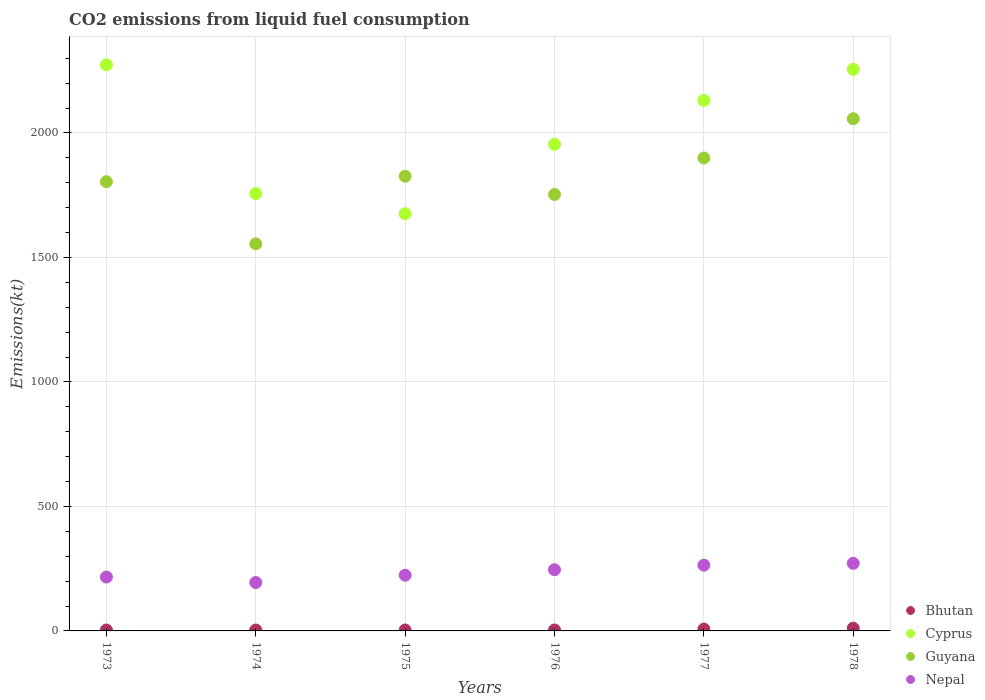Is the number of dotlines equal to the number of legend labels?
Offer a terse response. Yes. What is the amount of CO2 emitted in Cyprus in 1978?
Ensure brevity in your answer.  2255.2. Across all years, what is the maximum amount of CO2 emitted in Guyana?
Make the answer very short. 2057.19. Across all years, what is the minimum amount of CO2 emitted in Nepal?
Provide a succinct answer. 194.35. In which year was the amount of CO2 emitted in Bhutan maximum?
Your response must be concise. 1978. In which year was the amount of CO2 emitted in Guyana minimum?
Your answer should be very brief. 1974. What is the total amount of CO2 emitted in Bhutan in the graph?
Offer a terse response. 33. What is the difference between the amount of CO2 emitted in Nepal in 1974 and that in 1975?
Offer a very short reply. -29.34. What is the difference between the amount of CO2 emitted in Bhutan in 1973 and the amount of CO2 emitted in Guyana in 1975?
Provide a short and direct response. -1822.5. What is the average amount of CO2 emitted in Nepal per year?
Keep it short and to the point. 235.91. In the year 1974, what is the difference between the amount of CO2 emitted in Bhutan and amount of CO2 emitted in Nepal?
Make the answer very short. -190.68. In how many years, is the amount of CO2 emitted in Nepal greater than 800 kt?
Give a very brief answer. 0. What is the ratio of the amount of CO2 emitted in Guyana in 1974 to that in 1977?
Provide a succinct answer. 0.82. Is the amount of CO2 emitted in Guyana in 1973 less than that in 1975?
Give a very brief answer. Yes. What is the difference between the highest and the second highest amount of CO2 emitted in Bhutan?
Provide a short and direct response. 3.67. What is the difference between the highest and the lowest amount of CO2 emitted in Guyana?
Provide a short and direct response. 502.38. Is the sum of the amount of CO2 emitted in Cyprus in 1974 and 1977 greater than the maximum amount of CO2 emitted in Guyana across all years?
Your answer should be compact. Yes. Is it the case that in every year, the sum of the amount of CO2 emitted in Bhutan and amount of CO2 emitted in Nepal  is greater than the amount of CO2 emitted in Guyana?
Offer a very short reply. No. Does the amount of CO2 emitted in Bhutan monotonically increase over the years?
Your response must be concise. No. Is the amount of CO2 emitted in Cyprus strictly greater than the amount of CO2 emitted in Bhutan over the years?
Your answer should be compact. Yes. How many dotlines are there?
Your answer should be compact. 4. How many legend labels are there?
Ensure brevity in your answer.  4. What is the title of the graph?
Keep it short and to the point. CO2 emissions from liquid fuel consumption. Does "Senegal" appear as one of the legend labels in the graph?
Offer a terse response. No. What is the label or title of the Y-axis?
Offer a very short reply. Emissions(kt). What is the Emissions(kt) in Bhutan in 1973?
Make the answer very short. 3.67. What is the Emissions(kt) in Cyprus in 1973?
Give a very brief answer. 2273.54. What is the Emissions(kt) in Guyana in 1973?
Provide a succinct answer. 1804.16. What is the Emissions(kt) of Nepal in 1973?
Provide a succinct answer. 216.35. What is the Emissions(kt) in Bhutan in 1974?
Ensure brevity in your answer.  3.67. What is the Emissions(kt) in Cyprus in 1974?
Offer a very short reply. 1756.49. What is the Emissions(kt) in Guyana in 1974?
Offer a terse response. 1554.81. What is the Emissions(kt) of Nepal in 1974?
Provide a short and direct response. 194.35. What is the Emissions(kt) in Bhutan in 1975?
Ensure brevity in your answer.  3.67. What is the Emissions(kt) in Cyprus in 1975?
Provide a short and direct response. 1675.82. What is the Emissions(kt) in Guyana in 1975?
Offer a terse response. 1826.17. What is the Emissions(kt) of Nepal in 1975?
Ensure brevity in your answer.  223.69. What is the Emissions(kt) of Bhutan in 1976?
Your response must be concise. 3.67. What is the Emissions(kt) in Cyprus in 1976?
Your answer should be very brief. 1954.51. What is the Emissions(kt) in Guyana in 1976?
Your answer should be very brief. 1752.83. What is the Emissions(kt) of Nepal in 1976?
Provide a short and direct response. 245.69. What is the Emissions(kt) of Bhutan in 1977?
Your answer should be compact. 7.33. What is the Emissions(kt) of Cyprus in 1977?
Your answer should be compact. 2130.53. What is the Emissions(kt) of Guyana in 1977?
Offer a terse response. 1899.51. What is the Emissions(kt) in Nepal in 1977?
Give a very brief answer. 264.02. What is the Emissions(kt) in Bhutan in 1978?
Your response must be concise. 11. What is the Emissions(kt) of Cyprus in 1978?
Ensure brevity in your answer.  2255.2. What is the Emissions(kt) of Guyana in 1978?
Your answer should be compact. 2057.19. What is the Emissions(kt) in Nepal in 1978?
Ensure brevity in your answer.  271.36. Across all years, what is the maximum Emissions(kt) in Bhutan?
Make the answer very short. 11. Across all years, what is the maximum Emissions(kt) of Cyprus?
Ensure brevity in your answer.  2273.54. Across all years, what is the maximum Emissions(kt) in Guyana?
Offer a very short reply. 2057.19. Across all years, what is the maximum Emissions(kt) of Nepal?
Provide a succinct answer. 271.36. Across all years, what is the minimum Emissions(kt) in Bhutan?
Your answer should be compact. 3.67. Across all years, what is the minimum Emissions(kt) of Cyprus?
Make the answer very short. 1675.82. Across all years, what is the minimum Emissions(kt) of Guyana?
Provide a short and direct response. 1554.81. Across all years, what is the minimum Emissions(kt) in Nepal?
Offer a terse response. 194.35. What is the total Emissions(kt) in Bhutan in the graph?
Your answer should be compact. 33. What is the total Emissions(kt) in Cyprus in the graph?
Your answer should be compact. 1.20e+04. What is the total Emissions(kt) of Guyana in the graph?
Provide a succinct answer. 1.09e+04. What is the total Emissions(kt) of Nepal in the graph?
Make the answer very short. 1415.46. What is the difference between the Emissions(kt) of Cyprus in 1973 and that in 1974?
Provide a short and direct response. 517.05. What is the difference between the Emissions(kt) of Guyana in 1973 and that in 1974?
Ensure brevity in your answer.  249.36. What is the difference between the Emissions(kt) in Nepal in 1973 and that in 1974?
Your answer should be very brief. 22. What is the difference between the Emissions(kt) of Bhutan in 1973 and that in 1975?
Provide a succinct answer. 0. What is the difference between the Emissions(kt) of Cyprus in 1973 and that in 1975?
Your answer should be compact. 597.72. What is the difference between the Emissions(kt) in Guyana in 1973 and that in 1975?
Offer a very short reply. -22. What is the difference between the Emissions(kt) in Nepal in 1973 and that in 1975?
Offer a terse response. -7.33. What is the difference between the Emissions(kt) in Cyprus in 1973 and that in 1976?
Provide a succinct answer. 319.03. What is the difference between the Emissions(kt) in Guyana in 1973 and that in 1976?
Your answer should be compact. 51.34. What is the difference between the Emissions(kt) of Nepal in 1973 and that in 1976?
Give a very brief answer. -29.34. What is the difference between the Emissions(kt) in Bhutan in 1973 and that in 1977?
Offer a terse response. -3.67. What is the difference between the Emissions(kt) in Cyprus in 1973 and that in 1977?
Keep it short and to the point. 143.01. What is the difference between the Emissions(kt) of Guyana in 1973 and that in 1977?
Ensure brevity in your answer.  -95.34. What is the difference between the Emissions(kt) in Nepal in 1973 and that in 1977?
Provide a succinct answer. -47.67. What is the difference between the Emissions(kt) in Bhutan in 1973 and that in 1978?
Your answer should be very brief. -7.33. What is the difference between the Emissions(kt) of Cyprus in 1973 and that in 1978?
Offer a very short reply. 18.34. What is the difference between the Emissions(kt) in Guyana in 1973 and that in 1978?
Keep it short and to the point. -253.02. What is the difference between the Emissions(kt) of Nepal in 1973 and that in 1978?
Your response must be concise. -55.01. What is the difference between the Emissions(kt) in Bhutan in 1974 and that in 1975?
Your response must be concise. 0. What is the difference between the Emissions(kt) of Cyprus in 1974 and that in 1975?
Ensure brevity in your answer.  80.67. What is the difference between the Emissions(kt) of Guyana in 1974 and that in 1975?
Give a very brief answer. -271.36. What is the difference between the Emissions(kt) of Nepal in 1974 and that in 1975?
Offer a terse response. -29.34. What is the difference between the Emissions(kt) of Cyprus in 1974 and that in 1976?
Provide a short and direct response. -198.02. What is the difference between the Emissions(kt) in Guyana in 1974 and that in 1976?
Your answer should be compact. -198.02. What is the difference between the Emissions(kt) in Nepal in 1974 and that in 1976?
Ensure brevity in your answer.  -51.34. What is the difference between the Emissions(kt) in Bhutan in 1974 and that in 1977?
Offer a very short reply. -3.67. What is the difference between the Emissions(kt) of Cyprus in 1974 and that in 1977?
Give a very brief answer. -374.03. What is the difference between the Emissions(kt) of Guyana in 1974 and that in 1977?
Your response must be concise. -344.7. What is the difference between the Emissions(kt) in Nepal in 1974 and that in 1977?
Offer a terse response. -69.67. What is the difference between the Emissions(kt) of Bhutan in 1974 and that in 1978?
Give a very brief answer. -7.33. What is the difference between the Emissions(kt) of Cyprus in 1974 and that in 1978?
Provide a short and direct response. -498.71. What is the difference between the Emissions(kt) of Guyana in 1974 and that in 1978?
Provide a short and direct response. -502.38. What is the difference between the Emissions(kt) in Nepal in 1974 and that in 1978?
Ensure brevity in your answer.  -77.01. What is the difference between the Emissions(kt) of Bhutan in 1975 and that in 1976?
Your answer should be compact. 0. What is the difference between the Emissions(kt) of Cyprus in 1975 and that in 1976?
Offer a very short reply. -278.69. What is the difference between the Emissions(kt) of Guyana in 1975 and that in 1976?
Give a very brief answer. 73.34. What is the difference between the Emissions(kt) of Nepal in 1975 and that in 1976?
Offer a very short reply. -22. What is the difference between the Emissions(kt) of Bhutan in 1975 and that in 1977?
Make the answer very short. -3.67. What is the difference between the Emissions(kt) of Cyprus in 1975 and that in 1977?
Offer a very short reply. -454.71. What is the difference between the Emissions(kt) of Guyana in 1975 and that in 1977?
Your answer should be very brief. -73.34. What is the difference between the Emissions(kt) in Nepal in 1975 and that in 1977?
Give a very brief answer. -40.34. What is the difference between the Emissions(kt) of Bhutan in 1975 and that in 1978?
Give a very brief answer. -7.33. What is the difference between the Emissions(kt) in Cyprus in 1975 and that in 1978?
Your answer should be compact. -579.39. What is the difference between the Emissions(kt) in Guyana in 1975 and that in 1978?
Provide a succinct answer. -231.02. What is the difference between the Emissions(kt) in Nepal in 1975 and that in 1978?
Offer a very short reply. -47.67. What is the difference between the Emissions(kt) in Bhutan in 1976 and that in 1977?
Offer a terse response. -3.67. What is the difference between the Emissions(kt) in Cyprus in 1976 and that in 1977?
Ensure brevity in your answer.  -176.02. What is the difference between the Emissions(kt) of Guyana in 1976 and that in 1977?
Provide a short and direct response. -146.68. What is the difference between the Emissions(kt) of Nepal in 1976 and that in 1977?
Your answer should be compact. -18.34. What is the difference between the Emissions(kt) of Bhutan in 1976 and that in 1978?
Offer a terse response. -7.33. What is the difference between the Emissions(kt) in Cyprus in 1976 and that in 1978?
Your response must be concise. -300.69. What is the difference between the Emissions(kt) of Guyana in 1976 and that in 1978?
Your response must be concise. -304.36. What is the difference between the Emissions(kt) in Nepal in 1976 and that in 1978?
Give a very brief answer. -25.67. What is the difference between the Emissions(kt) of Bhutan in 1977 and that in 1978?
Offer a very short reply. -3.67. What is the difference between the Emissions(kt) in Cyprus in 1977 and that in 1978?
Offer a very short reply. -124.68. What is the difference between the Emissions(kt) in Guyana in 1977 and that in 1978?
Give a very brief answer. -157.68. What is the difference between the Emissions(kt) in Nepal in 1977 and that in 1978?
Offer a terse response. -7.33. What is the difference between the Emissions(kt) in Bhutan in 1973 and the Emissions(kt) in Cyprus in 1974?
Your answer should be very brief. -1752.83. What is the difference between the Emissions(kt) of Bhutan in 1973 and the Emissions(kt) of Guyana in 1974?
Give a very brief answer. -1551.14. What is the difference between the Emissions(kt) in Bhutan in 1973 and the Emissions(kt) in Nepal in 1974?
Make the answer very short. -190.68. What is the difference between the Emissions(kt) in Cyprus in 1973 and the Emissions(kt) in Guyana in 1974?
Offer a very short reply. 718.73. What is the difference between the Emissions(kt) in Cyprus in 1973 and the Emissions(kt) in Nepal in 1974?
Your answer should be compact. 2079.19. What is the difference between the Emissions(kt) of Guyana in 1973 and the Emissions(kt) of Nepal in 1974?
Your response must be concise. 1609.81. What is the difference between the Emissions(kt) of Bhutan in 1973 and the Emissions(kt) of Cyprus in 1975?
Your answer should be very brief. -1672.15. What is the difference between the Emissions(kt) of Bhutan in 1973 and the Emissions(kt) of Guyana in 1975?
Offer a terse response. -1822.5. What is the difference between the Emissions(kt) in Bhutan in 1973 and the Emissions(kt) in Nepal in 1975?
Provide a succinct answer. -220.02. What is the difference between the Emissions(kt) of Cyprus in 1973 and the Emissions(kt) of Guyana in 1975?
Keep it short and to the point. 447.37. What is the difference between the Emissions(kt) in Cyprus in 1973 and the Emissions(kt) in Nepal in 1975?
Offer a very short reply. 2049.85. What is the difference between the Emissions(kt) in Guyana in 1973 and the Emissions(kt) in Nepal in 1975?
Provide a short and direct response. 1580.48. What is the difference between the Emissions(kt) in Bhutan in 1973 and the Emissions(kt) in Cyprus in 1976?
Offer a terse response. -1950.84. What is the difference between the Emissions(kt) in Bhutan in 1973 and the Emissions(kt) in Guyana in 1976?
Keep it short and to the point. -1749.16. What is the difference between the Emissions(kt) in Bhutan in 1973 and the Emissions(kt) in Nepal in 1976?
Your answer should be very brief. -242.02. What is the difference between the Emissions(kt) in Cyprus in 1973 and the Emissions(kt) in Guyana in 1976?
Provide a short and direct response. 520.71. What is the difference between the Emissions(kt) in Cyprus in 1973 and the Emissions(kt) in Nepal in 1976?
Ensure brevity in your answer.  2027.85. What is the difference between the Emissions(kt) of Guyana in 1973 and the Emissions(kt) of Nepal in 1976?
Make the answer very short. 1558.47. What is the difference between the Emissions(kt) in Bhutan in 1973 and the Emissions(kt) in Cyprus in 1977?
Your response must be concise. -2126.86. What is the difference between the Emissions(kt) of Bhutan in 1973 and the Emissions(kt) of Guyana in 1977?
Give a very brief answer. -1895.84. What is the difference between the Emissions(kt) of Bhutan in 1973 and the Emissions(kt) of Nepal in 1977?
Offer a terse response. -260.36. What is the difference between the Emissions(kt) of Cyprus in 1973 and the Emissions(kt) of Guyana in 1977?
Offer a very short reply. 374.03. What is the difference between the Emissions(kt) in Cyprus in 1973 and the Emissions(kt) in Nepal in 1977?
Ensure brevity in your answer.  2009.52. What is the difference between the Emissions(kt) of Guyana in 1973 and the Emissions(kt) of Nepal in 1977?
Provide a succinct answer. 1540.14. What is the difference between the Emissions(kt) in Bhutan in 1973 and the Emissions(kt) in Cyprus in 1978?
Offer a terse response. -2251.54. What is the difference between the Emissions(kt) of Bhutan in 1973 and the Emissions(kt) of Guyana in 1978?
Your response must be concise. -2053.52. What is the difference between the Emissions(kt) in Bhutan in 1973 and the Emissions(kt) in Nepal in 1978?
Provide a succinct answer. -267.69. What is the difference between the Emissions(kt) in Cyprus in 1973 and the Emissions(kt) in Guyana in 1978?
Your answer should be compact. 216.35. What is the difference between the Emissions(kt) in Cyprus in 1973 and the Emissions(kt) in Nepal in 1978?
Ensure brevity in your answer.  2002.18. What is the difference between the Emissions(kt) of Guyana in 1973 and the Emissions(kt) of Nepal in 1978?
Ensure brevity in your answer.  1532.81. What is the difference between the Emissions(kt) of Bhutan in 1974 and the Emissions(kt) of Cyprus in 1975?
Keep it short and to the point. -1672.15. What is the difference between the Emissions(kt) of Bhutan in 1974 and the Emissions(kt) of Guyana in 1975?
Make the answer very short. -1822.5. What is the difference between the Emissions(kt) in Bhutan in 1974 and the Emissions(kt) in Nepal in 1975?
Your answer should be compact. -220.02. What is the difference between the Emissions(kt) in Cyprus in 1974 and the Emissions(kt) in Guyana in 1975?
Ensure brevity in your answer.  -69.67. What is the difference between the Emissions(kt) of Cyprus in 1974 and the Emissions(kt) of Nepal in 1975?
Your answer should be very brief. 1532.81. What is the difference between the Emissions(kt) in Guyana in 1974 and the Emissions(kt) in Nepal in 1975?
Your answer should be compact. 1331.12. What is the difference between the Emissions(kt) of Bhutan in 1974 and the Emissions(kt) of Cyprus in 1976?
Keep it short and to the point. -1950.84. What is the difference between the Emissions(kt) in Bhutan in 1974 and the Emissions(kt) in Guyana in 1976?
Your response must be concise. -1749.16. What is the difference between the Emissions(kt) in Bhutan in 1974 and the Emissions(kt) in Nepal in 1976?
Offer a terse response. -242.02. What is the difference between the Emissions(kt) in Cyprus in 1974 and the Emissions(kt) in Guyana in 1976?
Offer a very short reply. 3.67. What is the difference between the Emissions(kt) in Cyprus in 1974 and the Emissions(kt) in Nepal in 1976?
Keep it short and to the point. 1510.8. What is the difference between the Emissions(kt) in Guyana in 1974 and the Emissions(kt) in Nepal in 1976?
Provide a short and direct response. 1309.12. What is the difference between the Emissions(kt) in Bhutan in 1974 and the Emissions(kt) in Cyprus in 1977?
Offer a very short reply. -2126.86. What is the difference between the Emissions(kt) of Bhutan in 1974 and the Emissions(kt) of Guyana in 1977?
Provide a succinct answer. -1895.84. What is the difference between the Emissions(kt) in Bhutan in 1974 and the Emissions(kt) in Nepal in 1977?
Provide a succinct answer. -260.36. What is the difference between the Emissions(kt) of Cyprus in 1974 and the Emissions(kt) of Guyana in 1977?
Provide a short and direct response. -143.01. What is the difference between the Emissions(kt) in Cyprus in 1974 and the Emissions(kt) in Nepal in 1977?
Offer a very short reply. 1492.47. What is the difference between the Emissions(kt) of Guyana in 1974 and the Emissions(kt) of Nepal in 1977?
Keep it short and to the point. 1290.78. What is the difference between the Emissions(kt) in Bhutan in 1974 and the Emissions(kt) in Cyprus in 1978?
Your answer should be compact. -2251.54. What is the difference between the Emissions(kt) of Bhutan in 1974 and the Emissions(kt) of Guyana in 1978?
Keep it short and to the point. -2053.52. What is the difference between the Emissions(kt) of Bhutan in 1974 and the Emissions(kt) of Nepal in 1978?
Your answer should be compact. -267.69. What is the difference between the Emissions(kt) in Cyprus in 1974 and the Emissions(kt) in Guyana in 1978?
Your response must be concise. -300.69. What is the difference between the Emissions(kt) of Cyprus in 1974 and the Emissions(kt) of Nepal in 1978?
Provide a short and direct response. 1485.13. What is the difference between the Emissions(kt) in Guyana in 1974 and the Emissions(kt) in Nepal in 1978?
Provide a short and direct response. 1283.45. What is the difference between the Emissions(kt) of Bhutan in 1975 and the Emissions(kt) of Cyprus in 1976?
Offer a very short reply. -1950.84. What is the difference between the Emissions(kt) in Bhutan in 1975 and the Emissions(kt) in Guyana in 1976?
Offer a very short reply. -1749.16. What is the difference between the Emissions(kt) of Bhutan in 1975 and the Emissions(kt) of Nepal in 1976?
Give a very brief answer. -242.02. What is the difference between the Emissions(kt) of Cyprus in 1975 and the Emissions(kt) of Guyana in 1976?
Make the answer very short. -77.01. What is the difference between the Emissions(kt) of Cyprus in 1975 and the Emissions(kt) of Nepal in 1976?
Keep it short and to the point. 1430.13. What is the difference between the Emissions(kt) of Guyana in 1975 and the Emissions(kt) of Nepal in 1976?
Give a very brief answer. 1580.48. What is the difference between the Emissions(kt) of Bhutan in 1975 and the Emissions(kt) of Cyprus in 1977?
Offer a very short reply. -2126.86. What is the difference between the Emissions(kt) in Bhutan in 1975 and the Emissions(kt) in Guyana in 1977?
Provide a short and direct response. -1895.84. What is the difference between the Emissions(kt) in Bhutan in 1975 and the Emissions(kt) in Nepal in 1977?
Offer a very short reply. -260.36. What is the difference between the Emissions(kt) of Cyprus in 1975 and the Emissions(kt) of Guyana in 1977?
Make the answer very short. -223.69. What is the difference between the Emissions(kt) of Cyprus in 1975 and the Emissions(kt) of Nepal in 1977?
Give a very brief answer. 1411.8. What is the difference between the Emissions(kt) in Guyana in 1975 and the Emissions(kt) in Nepal in 1977?
Give a very brief answer. 1562.14. What is the difference between the Emissions(kt) of Bhutan in 1975 and the Emissions(kt) of Cyprus in 1978?
Your answer should be compact. -2251.54. What is the difference between the Emissions(kt) in Bhutan in 1975 and the Emissions(kt) in Guyana in 1978?
Keep it short and to the point. -2053.52. What is the difference between the Emissions(kt) of Bhutan in 1975 and the Emissions(kt) of Nepal in 1978?
Make the answer very short. -267.69. What is the difference between the Emissions(kt) in Cyprus in 1975 and the Emissions(kt) in Guyana in 1978?
Offer a very short reply. -381.37. What is the difference between the Emissions(kt) of Cyprus in 1975 and the Emissions(kt) of Nepal in 1978?
Your answer should be very brief. 1404.46. What is the difference between the Emissions(kt) of Guyana in 1975 and the Emissions(kt) of Nepal in 1978?
Give a very brief answer. 1554.81. What is the difference between the Emissions(kt) of Bhutan in 1976 and the Emissions(kt) of Cyprus in 1977?
Give a very brief answer. -2126.86. What is the difference between the Emissions(kt) in Bhutan in 1976 and the Emissions(kt) in Guyana in 1977?
Your response must be concise. -1895.84. What is the difference between the Emissions(kt) in Bhutan in 1976 and the Emissions(kt) in Nepal in 1977?
Make the answer very short. -260.36. What is the difference between the Emissions(kt) in Cyprus in 1976 and the Emissions(kt) in Guyana in 1977?
Your response must be concise. 55.01. What is the difference between the Emissions(kt) in Cyprus in 1976 and the Emissions(kt) in Nepal in 1977?
Your answer should be very brief. 1690.49. What is the difference between the Emissions(kt) in Guyana in 1976 and the Emissions(kt) in Nepal in 1977?
Your answer should be very brief. 1488.8. What is the difference between the Emissions(kt) of Bhutan in 1976 and the Emissions(kt) of Cyprus in 1978?
Your answer should be very brief. -2251.54. What is the difference between the Emissions(kt) in Bhutan in 1976 and the Emissions(kt) in Guyana in 1978?
Keep it short and to the point. -2053.52. What is the difference between the Emissions(kt) in Bhutan in 1976 and the Emissions(kt) in Nepal in 1978?
Your answer should be compact. -267.69. What is the difference between the Emissions(kt) of Cyprus in 1976 and the Emissions(kt) of Guyana in 1978?
Provide a succinct answer. -102.68. What is the difference between the Emissions(kt) of Cyprus in 1976 and the Emissions(kt) of Nepal in 1978?
Your answer should be compact. 1683.15. What is the difference between the Emissions(kt) in Guyana in 1976 and the Emissions(kt) in Nepal in 1978?
Provide a short and direct response. 1481.47. What is the difference between the Emissions(kt) in Bhutan in 1977 and the Emissions(kt) in Cyprus in 1978?
Keep it short and to the point. -2247.87. What is the difference between the Emissions(kt) in Bhutan in 1977 and the Emissions(kt) in Guyana in 1978?
Your answer should be compact. -2049.85. What is the difference between the Emissions(kt) of Bhutan in 1977 and the Emissions(kt) of Nepal in 1978?
Provide a short and direct response. -264.02. What is the difference between the Emissions(kt) of Cyprus in 1977 and the Emissions(kt) of Guyana in 1978?
Offer a very short reply. 73.34. What is the difference between the Emissions(kt) of Cyprus in 1977 and the Emissions(kt) of Nepal in 1978?
Offer a very short reply. 1859.17. What is the difference between the Emissions(kt) in Guyana in 1977 and the Emissions(kt) in Nepal in 1978?
Provide a short and direct response. 1628.15. What is the average Emissions(kt) in Bhutan per year?
Offer a terse response. 5.5. What is the average Emissions(kt) in Cyprus per year?
Your answer should be compact. 2007.68. What is the average Emissions(kt) of Guyana per year?
Offer a very short reply. 1815.78. What is the average Emissions(kt) of Nepal per year?
Give a very brief answer. 235.91. In the year 1973, what is the difference between the Emissions(kt) of Bhutan and Emissions(kt) of Cyprus?
Your response must be concise. -2269.87. In the year 1973, what is the difference between the Emissions(kt) in Bhutan and Emissions(kt) in Guyana?
Make the answer very short. -1800.5. In the year 1973, what is the difference between the Emissions(kt) of Bhutan and Emissions(kt) of Nepal?
Your response must be concise. -212.69. In the year 1973, what is the difference between the Emissions(kt) in Cyprus and Emissions(kt) in Guyana?
Give a very brief answer. 469.38. In the year 1973, what is the difference between the Emissions(kt) of Cyprus and Emissions(kt) of Nepal?
Keep it short and to the point. 2057.19. In the year 1973, what is the difference between the Emissions(kt) in Guyana and Emissions(kt) in Nepal?
Ensure brevity in your answer.  1587.81. In the year 1974, what is the difference between the Emissions(kt) of Bhutan and Emissions(kt) of Cyprus?
Ensure brevity in your answer.  -1752.83. In the year 1974, what is the difference between the Emissions(kt) of Bhutan and Emissions(kt) of Guyana?
Make the answer very short. -1551.14. In the year 1974, what is the difference between the Emissions(kt) of Bhutan and Emissions(kt) of Nepal?
Offer a terse response. -190.68. In the year 1974, what is the difference between the Emissions(kt) of Cyprus and Emissions(kt) of Guyana?
Keep it short and to the point. 201.69. In the year 1974, what is the difference between the Emissions(kt) in Cyprus and Emissions(kt) in Nepal?
Offer a very short reply. 1562.14. In the year 1974, what is the difference between the Emissions(kt) of Guyana and Emissions(kt) of Nepal?
Give a very brief answer. 1360.46. In the year 1975, what is the difference between the Emissions(kt) in Bhutan and Emissions(kt) in Cyprus?
Make the answer very short. -1672.15. In the year 1975, what is the difference between the Emissions(kt) of Bhutan and Emissions(kt) of Guyana?
Offer a terse response. -1822.5. In the year 1975, what is the difference between the Emissions(kt) of Bhutan and Emissions(kt) of Nepal?
Give a very brief answer. -220.02. In the year 1975, what is the difference between the Emissions(kt) in Cyprus and Emissions(kt) in Guyana?
Make the answer very short. -150.35. In the year 1975, what is the difference between the Emissions(kt) of Cyprus and Emissions(kt) of Nepal?
Offer a terse response. 1452.13. In the year 1975, what is the difference between the Emissions(kt) in Guyana and Emissions(kt) in Nepal?
Provide a succinct answer. 1602.48. In the year 1976, what is the difference between the Emissions(kt) of Bhutan and Emissions(kt) of Cyprus?
Give a very brief answer. -1950.84. In the year 1976, what is the difference between the Emissions(kt) of Bhutan and Emissions(kt) of Guyana?
Your answer should be very brief. -1749.16. In the year 1976, what is the difference between the Emissions(kt) in Bhutan and Emissions(kt) in Nepal?
Give a very brief answer. -242.02. In the year 1976, what is the difference between the Emissions(kt) in Cyprus and Emissions(kt) in Guyana?
Your answer should be very brief. 201.69. In the year 1976, what is the difference between the Emissions(kt) of Cyprus and Emissions(kt) of Nepal?
Your response must be concise. 1708.82. In the year 1976, what is the difference between the Emissions(kt) in Guyana and Emissions(kt) in Nepal?
Provide a short and direct response. 1507.14. In the year 1977, what is the difference between the Emissions(kt) in Bhutan and Emissions(kt) in Cyprus?
Make the answer very short. -2123.19. In the year 1977, what is the difference between the Emissions(kt) of Bhutan and Emissions(kt) of Guyana?
Give a very brief answer. -1892.17. In the year 1977, what is the difference between the Emissions(kt) in Bhutan and Emissions(kt) in Nepal?
Your answer should be compact. -256.69. In the year 1977, what is the difference between the Emissions(kt) in Cyprus and Emissions(kt) in Guyana?
Provide a short and direct response. 231.02. In the year 1977, what is the difference between the Emissions(kt) in Cyprus and Emissions(kt) in Nepal?
Give a very brief answer. 1866.5. In the year 1977, what is the difference between the Emissions(kt) of Guyana and Emissions(kt) of Nepal?
Ensure brevity in your answer.  1635.48. In the year 1978, what is the difference between the Emissions(kt) of Bhutan and Emissions(kt) of Cyprus?
Make the answer very short. -2244.2. In the year 1978, what is the difference between the Emissions(kt) of Bhutan and Emissions(kt) of Guyana?
Your answer should be very brief. -2046.19. In the year 1978, what is the difference between the Emissions(kt) of Bhutan and Emissions(kt) of Nepal?
Make the answer very short. -260.36. In the year 1978, what is the difference between the Emissions(kt) in Cyprus and Emissions(kt) in Guyana?
Offer a very short reply. 198.02. In the year 1978, what is the difference between the Emissions(kt) of Cyprus and Emissions(kt) of Nepal?
Provide a succinct answer. 1983.85. In the year 1978, what is the difference between the Emissions(kt) of Guyana and Emissions(kt) of Nepal?
Your answer should be compact. 1785.83. What is the ratio of the Emissions(kt) of Cyprus in 1973 to that in 1974?
Offer a very short reply. 1.29. What is the ratio of the Emissions(kt) of Guyana in 1973 to that in 1974?
Offer a terse response. 1.16. What is the ratio of the Emissions(kt) in Nepal in 1973 to that in 1974?
Offer a terse response. 1.11. What is the ratio of the Emissions(kt) in Bhutan in 1973 to that in 1975?
Ensure brevity in your answer.  1. What is the ratio of the Emissions(kt) in Cyprus in 1973 to that in 1975?
Make the answer very short. 1.36. What is the ratio of the Emissions(kt) in Nepal in 1973 to that in 1975?
Provide a short and direct response. 0.97. What is the ratio of the Emissions(kt) of Bhutan in 1973 to that in 1976?
Offer a very short reply. 1. What is the ratio of the Emissions(kt) in Cyprus in 1973 to that in 1976?
Your answer should be very brief. 1.16. What is the ratio of the Emissions(kt) of Guyana in 1973 to that in 1976?
Offer a very short reply. 1.03. What is the ratio of the Emissions(kt) in Nepal in 1973 to that in 1976?
Your response must be concise. 0.88. What is the ratio of the Emissions(kt) of Bhutan in 1973 to that in 1977?
Offer a terse response. 0.5. What is the ratio of the Emissions(kt) of Cyprus in 1973 to that in 1977?
Your answer should be compact. 1.07. What is the ratio of the Emissions(kt) in Guyana in 1973 to that in 1977?
Offer a terse response. 0.95. What is the ratio of the Emissions(kt) of Nepal in 1973 to that in 1977?
Keep it short and to the point. 0.82. What is the ratio of the Emissions(kt) of Bhutan in 1973 to that in 1978?
Offer a very short reply. 0.33. What is the ratio of the Emissions(kt) of Guyana in 1973 to that in 1978?
Provide a short and direct response. 0.88. What is the ratio of the Emissions(kt) in Nepal in 1973 to that in 1978?
Provide a succinct answer. 0.8. What is the ratio of the Emissions(kt) in Cyprus in 1974 to that in 1975?
Offer a terse response. 1.05. What is the ratio of the Emissions(kt) in Guyana in 1974 to that in 1975?
Give a very brief answer. 0.85. What is the ratio of the Emissions(kt) of Nepal in 1974 to that in 1975?
Your response must be concise. 0.87. What is the ratio of the Emissions(kt) of Bhutan in 1974 to that in 1976?
Your answer should be very brief. 1. What is the ratio of the Emissions(kt) of Cyprus in 1974 to that in 1976?
Ensure brevity in your answer.  0.9. What is the ratio of the Emissions(kt) in Guyana in 1974 to that in 1976?
Offer a very short reply. 0.89. What is the ratio of the Emissions(kt) in Nepal in 1974 to that in 1976?
Ensure brevity in your answer.  0.79. What is the ratio of the Emissions(kt) of Bhutan in 1974 to that in 1977?
Offer a terse response. 0.5. What is the ratio of the Emissions(kt) in Cyprus in 1974 to that in 1977?
Make the answer very short. 0.82. What is the ratio of the Emissions(kt) in Guyana in 1974 to that in 1977?
Your response must be concise. 0.82. What is the ratio of the Emissions(kt) of Nepal in 1974 to that in 1977?
Your response must be concise. 0.74. What is the ratio of the Emissions(kt) of Bhutan in 1974 to that in 1978?
Give a very brief answer. 0.33. What is the ratio of the Emissions(kt) of Cyprus in 1974 to that in 1978?
Keep it short and to the point. 0.78. What is the ratio of the Emissions(kt) of Guyana in 1974 to that in 1978?
Keep it short and to the point. 0.76. What is the ratio of the Emissions(kt) in Nepal in 1974 to that in 1978?
Provide a succinct answer. 0.72. What is the ratio of the Emissions(kt) in Cyprus in 1975 to that in 1976?
Provide a succinct answer. 0.86. What is the ratio of the Emissions(kt) in Guyana in 1975 to that in 1976?
Ensure brevity in your answer.  1.04. What is the ratio of the Emissions(kt) in Nepal in 1975 to that in 1976?
Your answer should be very brief. 0.91. What is the ratio of the Emissions(kt) of Bhutan in 1975 to that in 1977?
Your answer should be very brief. 0.5. What is the ratio of the Emissions(kt) in Cyprus in 1975 to that in 1977?
Give a very brief answer. 0.79. What is the ratio of the Emissions(kt) of Guyana in 1975 to that in 1977?
Make the answer very short. 0.96. What is the ratio of the Emissions(kt) of Nepal in 1975 to that in 1977?
Your response must be concise. 0.85. What is the ratio of the Emissions(kt) in Bhutan in 1975 to that in 1978?
Your answer should be very brief. 0.33. What is the ratio of the Emissions(kt) in Cyprus in 1975 to that in 1978?
Keep it short and to the point. 0.74. What is the ratio of the Emissions(kt) in Guyana in 1975 to that in 1978?
Your answer should be compact. 0.89. What is the ratio of the Emissions(kt) in Nepal in 1975 to that in 1978?
Give a very brief answer. 0.82. What is the ratio of the Emissions(kt) in Bhutan in 1976 to that in 1977?
Your answer should be very brief. 0.5. What is the ratio of the Emissions(kt) of Cyprus in 1976 to that in 1977?
Your response must be concise. 0.92. What is the ratio of the Emissions(kt) of Guyana in 1976 to that in 1977?
Your response must be concise. 0.92. What is the ratio of the Emissions(kt) of Nepal in 1976 to that in 1977?
Provide a succinct answer. 0.93. What is the ratio of the Emissions(kt) in Cyprus in 1976 to that in 1978?
Provide a succinct answer. 0.87. What is the ratio of the Emissions(kt) in Guyana in 1976 to that in 1978?
Provide a succinct answer. 0.85. What is the ratio of the Emissions(kt) in Nepal in 1976 to that in 1978?
Offer a terse response. 0.91. What is the ratio of the Emissions(kt) of Bhutan in 1977 to that in 1978?
Your answer should be compact. 0.67. What is the ratio of the Emissions(kt) in Cyprus in 1977 to that in 1978?
Provide a succinct answer. 0.94. What is the ratio of the Emissions(kt) of Guyana in 1977 to that in 1978?
Provide a succinct answer. 0.92. What is the ratio of the Emissions(kt) of Nepal in 1977 to that in 1978?
Provide a succinct answer. 0.97. What is the difference between the highest and the second highest Emissions(kt) of Bhutan?
Your response must be concise. 3.67. What is the difference between the highest and the second highest Emissions(kt) of Cyprus?
Keep it short and to the point. 18.34. What is the difference between the highest and the second highest Emissions(kt) in Guyana?
Ensure brevity in your answer.  157.68. What is the difference between the highest and the second highest Emissions(kt) of Nepal?
Your answer should be compact. 7.33. What is the difference between the highest and the lowest Emissions(kt) of Bhutan?
Keep it short and to the point. 7.33. What is the difference between the highest and the lowest Emissions(kt) of Cyprus?
Your response must be concise. 597.72. What is the difference between the highest and the lowest Emissions(kt) in Guyana?
Your answer should be compact. 502.38. What is the difference between the highest and the lowest Emissions(kt) of Nepal?
Provide a succinct answer. 77.01. 